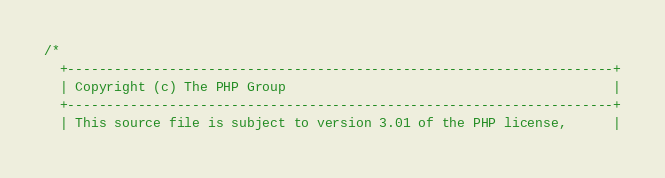<code> <loc_0><loc_0><loc_500><loc_500><_C_>/*
  +----------------------------------------------------------------------+
  | Copyright (c) The PHP Group                                          |
  +----------------------------------------------------------------------+
  | This source file is subject to version 3.01 of the PHP license,      |</code> 